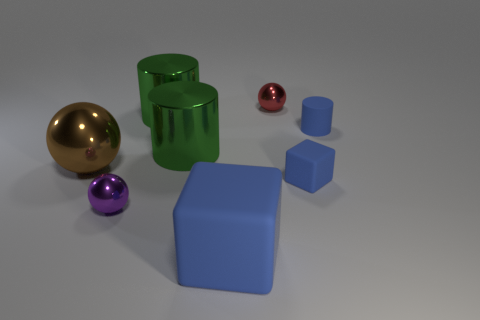Add 1 red metal blocks. How many objects exist? 9 Subtract all blocks. How many objects are left? 6 Add 4 green shiny things. How many green shiny things are left? 6 Add 8 large shiny cylinders. How many large shiny cylinders exist? 10 Subtract 2 blue blocks. How many objects are left? 6 Subtract all big blue things. Subtract all large purple matte cylinders. How many objects are left? 7 